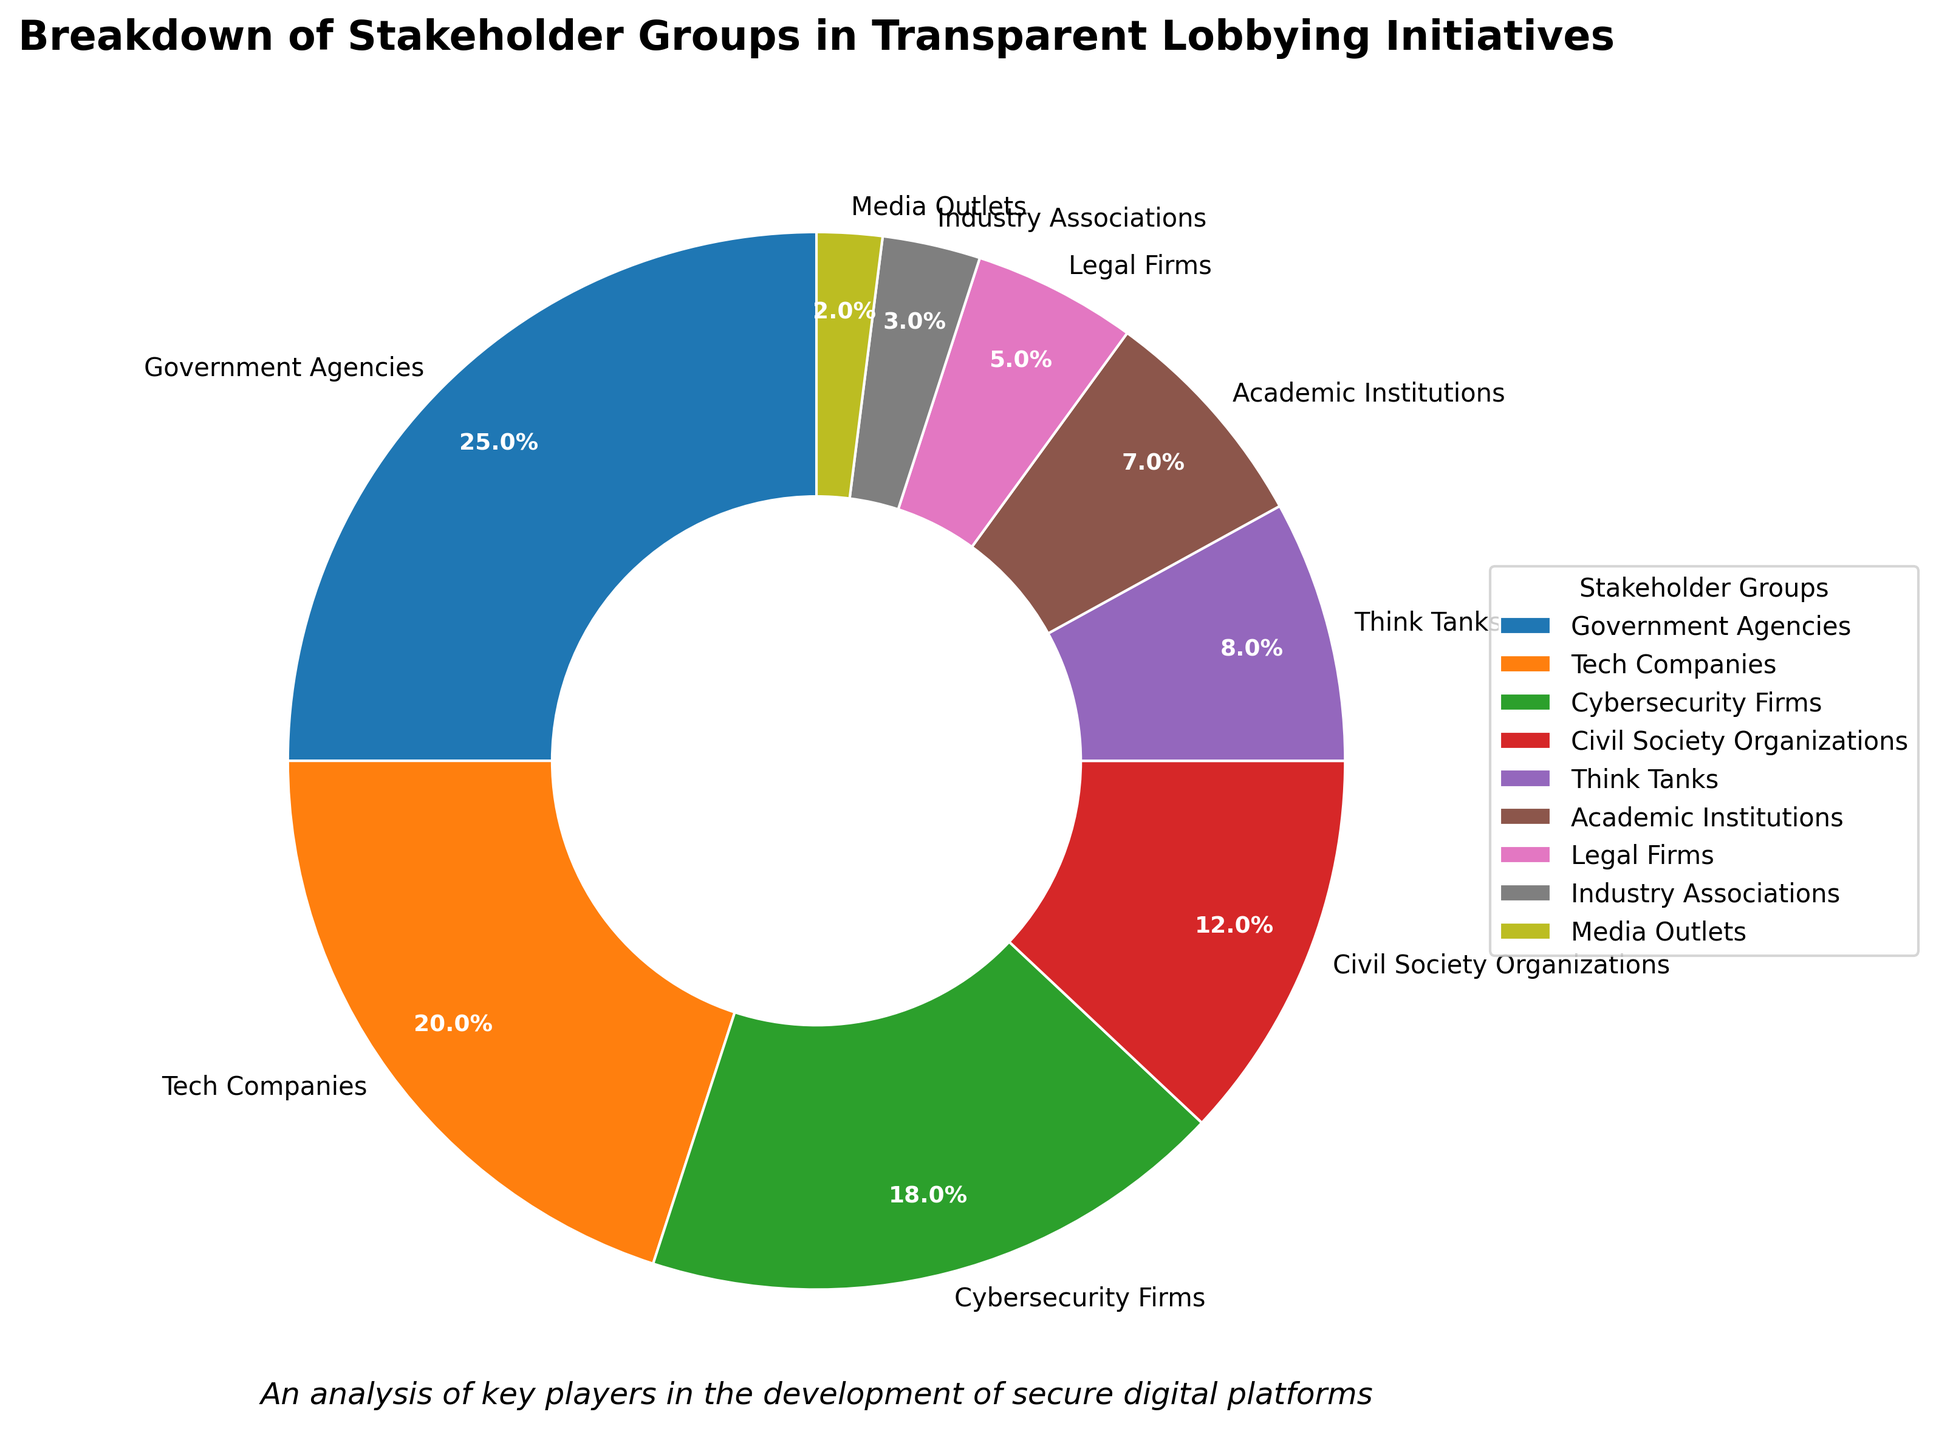What is the percentage of Cybersecurity Firms involved? The pie chart shows the percentage breakdown for each stakeholder group. Cybersecurity Firms are listed with a percentage value next to them.
Answer: 18% Which stakeholder group has the smallest percentage? By observing the pie chart, the stakeholder group with the smallest slice will have the smallest percentage. The legend confirms that Media Outlets have the smallest slice.
Answer: Media Outlets How many stakeholder groups have a percentage of 10% or higher? To find this, count the number of slices labeled with a percentage of 10% or higher.
Answer: 4 What is the combined percentage of Civil Society Organizations, Think Tanks, and Academic Institutions? Add the percentages of the three groups: Civil Society Organizations (12%), Think Tanks (8%), and Academic Institutions (7%). 12% + 8% + 7% = 27%.
Answer: 27% Which stakeholder group is more involved: Legal Firms or Government Agencies? Compare the percentages of Legal Firms and Government Agencies. Legal Firms have 5%, while Government Agencies have 25%.
Answer: Government Agencies What is the difference in the percentage between Tech Companies and Cybersecurity Firms? Subtract the percentage of Cybersecurity Firms (18%) from the percentage of Tech Companies (20%). 20% - 18% = 2%.
Answer: 2% Are Industry Associations or Academic Institutions more engaged in transparent lobbying initiatives? Compare the percentages of Industry Associations (3%) and Academic Institutions (7%).
Answer: Academic Institutions What is the average percentage involvement of Government Agencies, Tech Companies, and Cybersecurity Firms? Add the percentages: Government Agencies (25%), Tech Companies (20%), and Cybersecurity Firms (18%), then divide by 3. (25% + 20% + 18%) / 3 = 21%.
Answer: 21% Which stakeholder group is visually represented by the color blue? From the pie chart's color legend, identify the group labeled in blue.
Answer: Government Agencies Which stakeholder groups have a percentage less than 10%? Identify the slices with percentages less than 10% and list their group names: Think Tanks (8%), Academic Institutions (7%), Legal Firms (5%), Industry Associations (3%), Media Outlets (2%).
Answer: Think Tanks, Academic Institutions, Legal Firms, Industry Associations, Media Outlets 